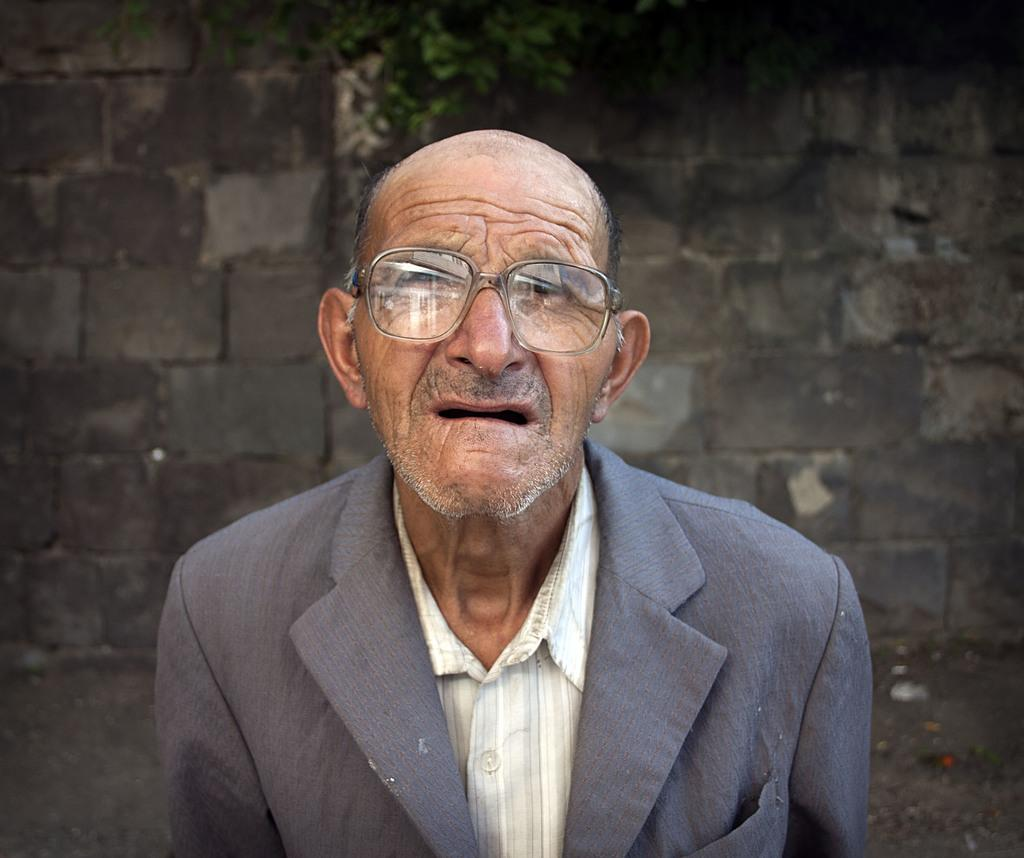What is the main subject in the foreground of the image? There is an old man in the foreground of the image. What can be seen in the background of the image? There is a wall and a plant in the background of the image. What type of flower is the old man holding in the image? There is no flower present in the image; the old man is not holding anything. 